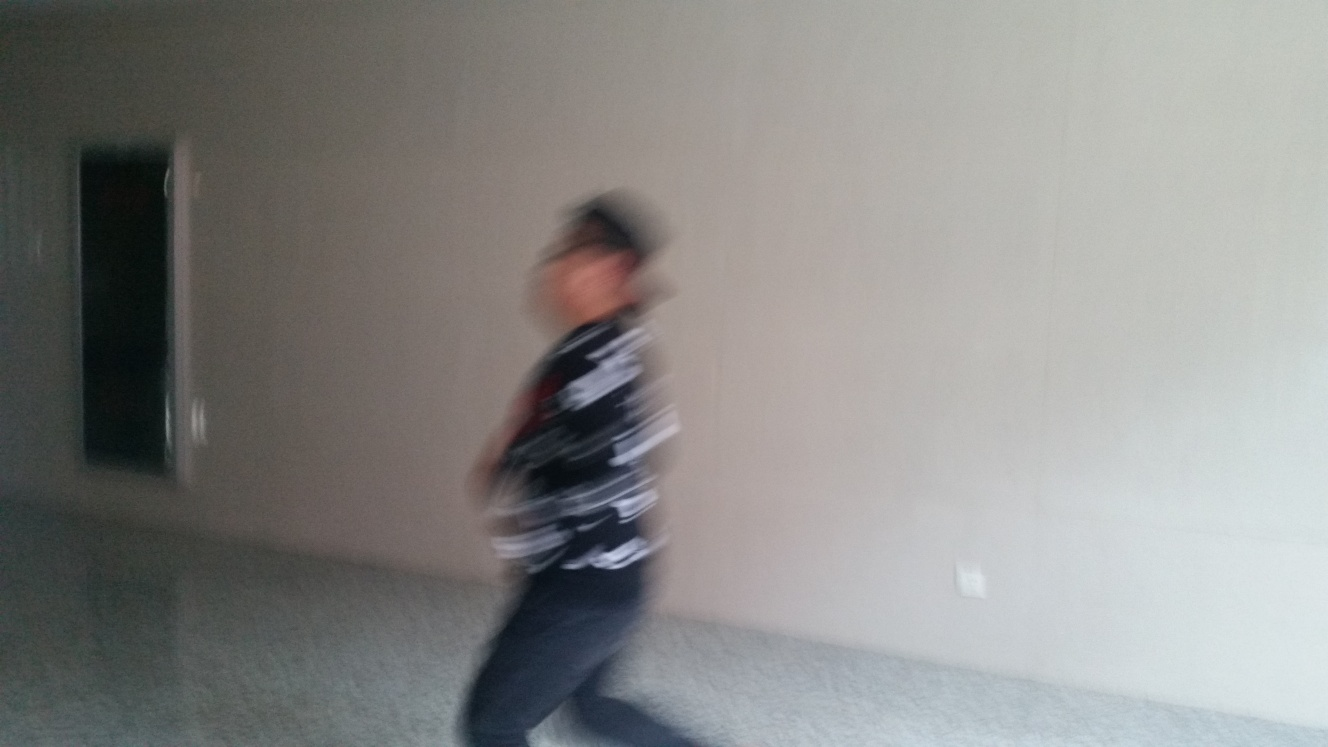Are there any quality issues with this image? Yes, the main subject of the image appears to be in motion, resulting in motion blur. The lighting conditions seem suboptimal, and the image is not in focus, which decreases overall sharpness and quality. 